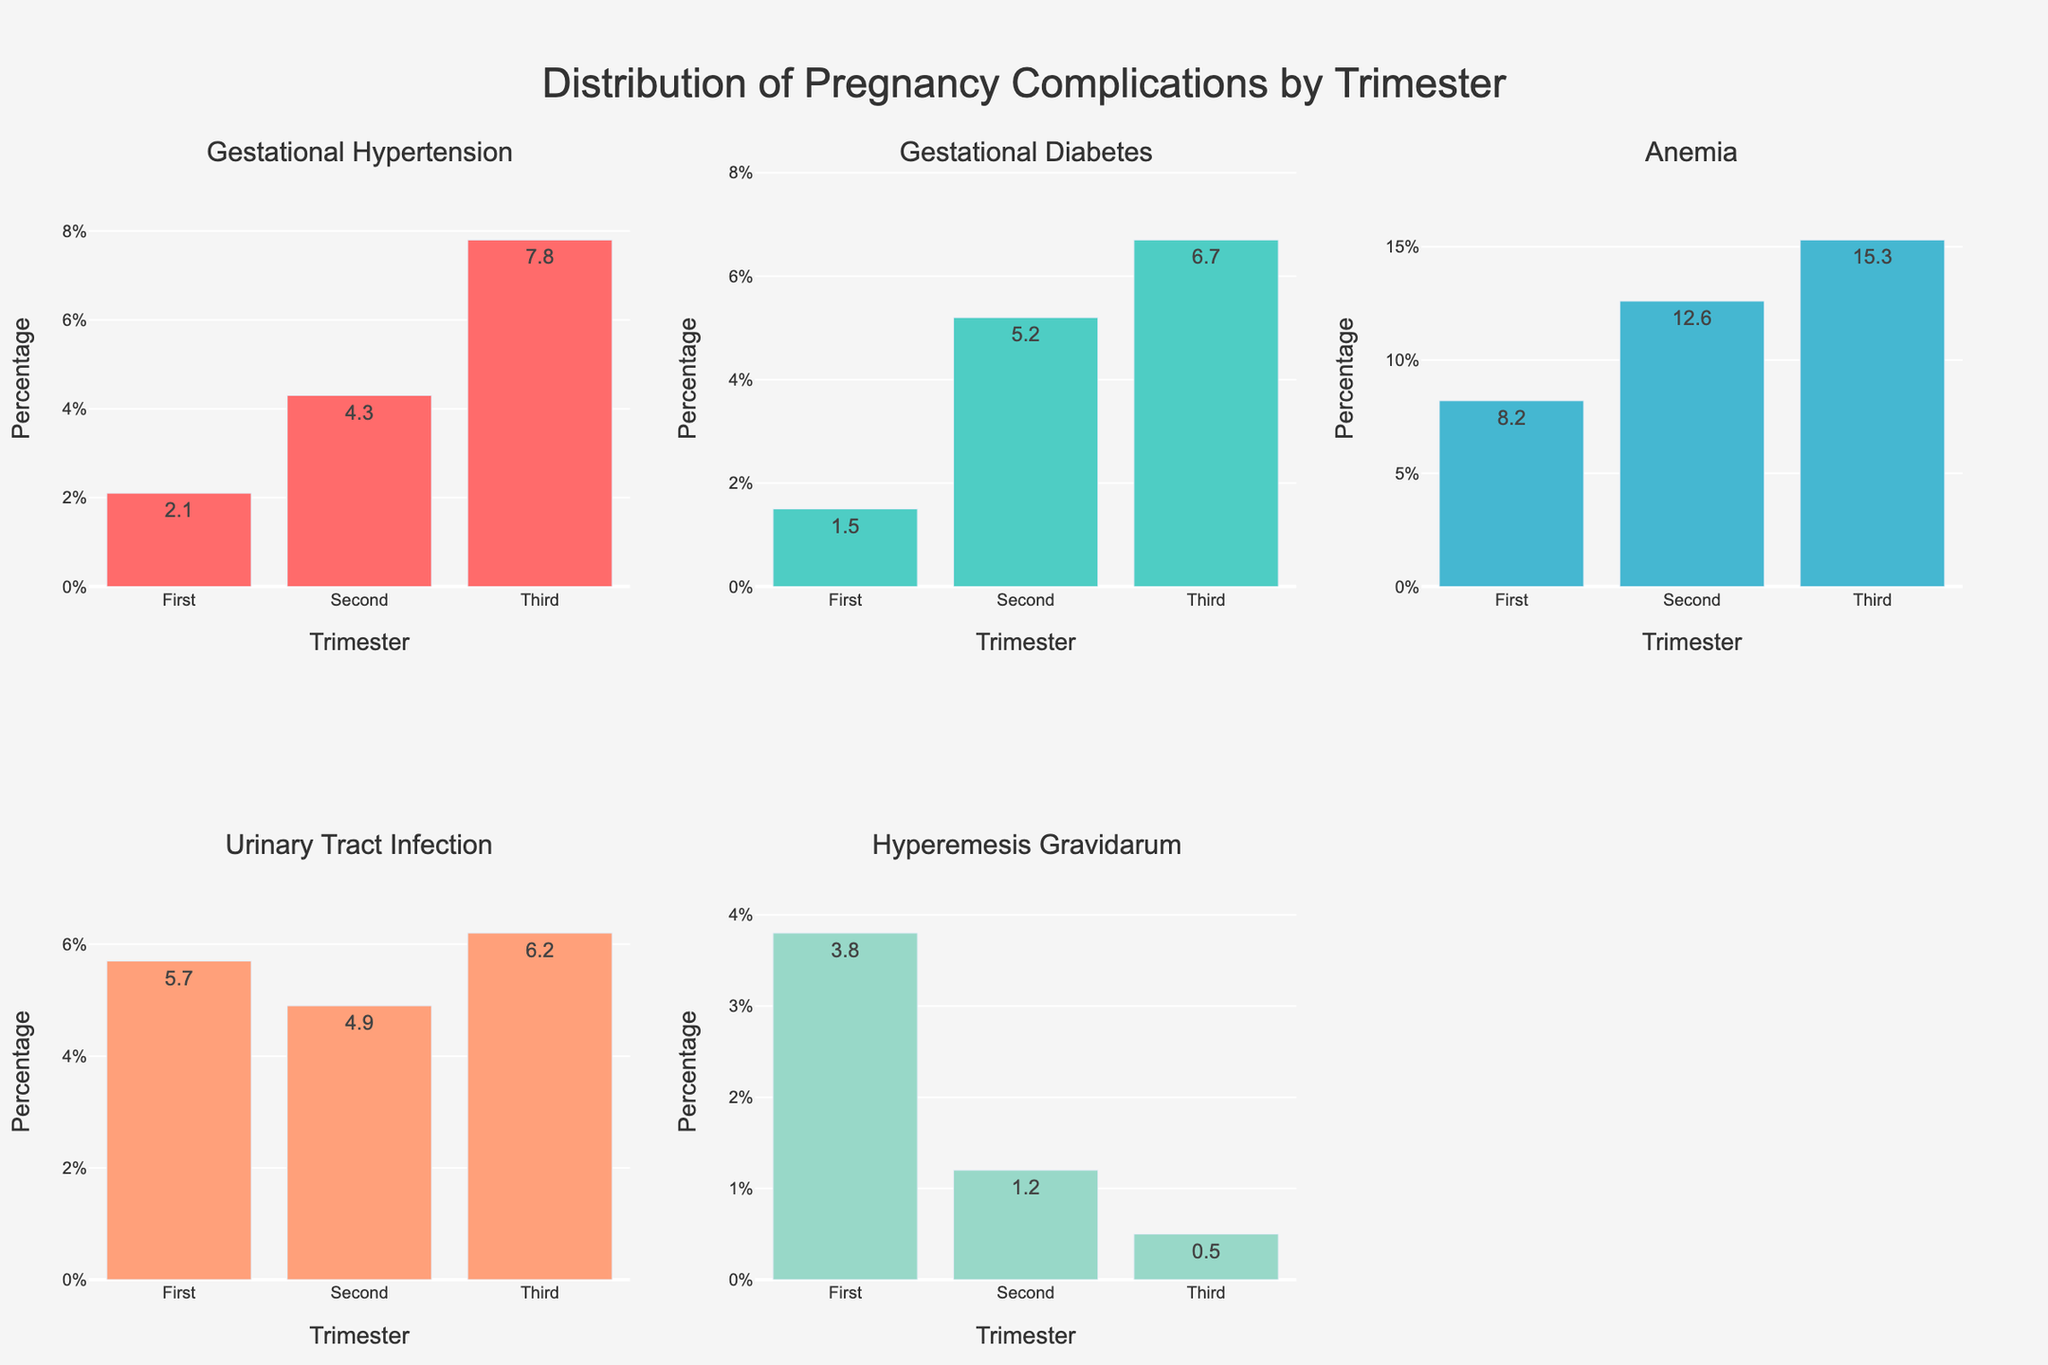What's the overall title of the plot? The title is displayed at the top of the figure. It reads "Distribution of Pregnancy Complications by Trimester"
Answer: Distribution of Pregnancy Complications by Trimester Which trimester has the highest reported percentage of hyperemesis gravidarum? Referring to the Hyperemesis Gravidarum subplot, the third bar representing the third trimester has the highest value compared to the first and second trimesters.
Answer: First trimester Among the three trimesters, how does the percentage of gestational hypertension change? The subplot for Gestational Hypertension shows an increasing trend from the first (2.1%) through the second (4.3%) to the third trimester (7.8%). The percentages increase consecutively across the trimesters.
Answer: Increases Compare the percentage of anemia between the second and third trimesters. Which one is higher and by how much? Referring to the Anemia subplot, the second trimester stands at 12.6%, while the third trimester is at 15.3%. The difference between the two trimesters is 15.3% - 12.6% = 2.7%.
Answer: Third trimester by 2.7% What is the sum of the percentages of urinary tract infection across all trimesters? In the Urinary Tract Infection subplot, the three bars represent 5.7% (first trimester), 4.9% (second trimester), and 6.2% (third trimester). Adding these values gives 5.7% + 4.9% + 6.2% = 16.8%.
Answer: 16.8% Between gestational diabetes and hyperemesis gravidarum, which has a higher peak percentage and what is that value? By reviewing their respective subplots, gestational diabetes has a peak of 6.7% in the third trimester, while hyperemesis gravidarum peaks at 3.8% in the first trimester. Thus, the highest peak is 6.7% for gestational diabetes.
Answer: Gestational diabetes, 6.7% Across all complications, which complication shows the highest percentage in any trimester? By looking at all subplots, anemia in the third trimester reaches the highest individual value at 15.3%.
Answer: Anemia in the third trimester Which two complications show a decrease in percentage from the second to the third trimester? Referring to their respective subplots, Urinary Tract Infection decreases from 4.9% in the second trimester to 6.2% in the third trimester, and Hyperemesis Gravidarum decreases from 1.2% to 0.5%.
Answer: Urinary Tract Infection and Hyperemesis Gravidarum What is the average percentage of gestational diabetes across all three trimesters? The Gestational Diabetes subplot shows percentages of 1.5% (first trimester), 5.2% (second trimester), and 6.7% (third trimester). Adding them gives 1.5% + 5.2% + 6.7% = 13.4%, and the average is 13.4% / 3 ≈ 4.47%.
Answer: 4.47% 